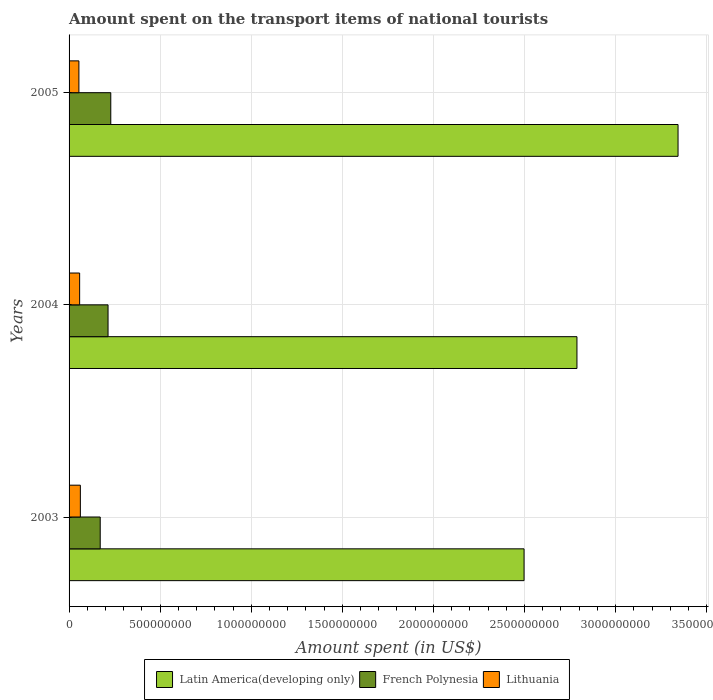How many different coloured bars are there?
Keep it short and to the point. 3. How many groups of bars are there?
Provide a succinct answer. 3. Are the number of bars per tick equal to the number of legend labels?
Provide a short and direct response. Yes. Are the number of bars on each tick of the Y-axis equal?
Offer a very short reply. Yes. How many bars are there on the 3rd tick from the bottom?
Offer a terse response. 3. In how many cases, is the number of bars for a given year not equal to the number of legend labels?
Ensure brevity in your answer.  0. What is the amount spent on the transport items of national tourists in Lithuania in 2005?
Give a very brief answer. 5.40e+07. Across all years, what is the maximum amount spent on the transport items of national tourists in French Polynesia?
Your response must be concise. 2.29e+08. Across all years, what is the minimum amount spent on the transport items of national tourists in French Polynesia?
Ensure brevity in your answer.  1.71e+08. In which year was the amount spent on the transport items of national tourists in Lithuania maximum?
Your response must be concise. 2003. What is the total amount spent on the transport items of national tourists in French Polynesia in the graph?
Offer a terse response. 6.14e+08. What is the difference between the amount spent on the transport items of national tourists in Latin America(developing only) in 2003 and that in 2005?
Offer a terse response. -8.45e+08. What is the difference between the amount spent on the transport items of national tourists in Latin America(developing only) in 2005 and the amount spent on the transport items of national tourists in French Polynesia in 2003?
Keep it short and to the point. 3.17e+09. What is the average amount spent on the transport items of national tourists in Latin America(developing only) per year?
Ensure brevity in your answer.  2.88e+09. In the year 2004, what is the difference between the amount spent on the transport items of national tourists in French Polynesia and amount spent on the transport items of national tourists in Lithuania?
Offer a very short reply. 1.56e+08. In how many years, is the amount spent on the transport items of national tourists in Lithuania greater than 2200000000 US$?
Offer a very short reply. 0. What is the ratio of the amount spent on the transport items of national tourists in Lithuania in 2004 to that in 2005?
Offer a very short reply. 1.07. What is the difference between the highest and the second highest amount spent on the transport items of national tourists in Lithuania?
Ensure brevity in your answer.  4.00e+06. What is the difference between the highest and the lowest amount spent on the transport items of national tourists in Latin America(developing only)?
Keep it short and to the point. 8.45e+08. Is the sum of the amount spent on the transport items of national tourists in French Polynesia in 2003 and 2005 greater than the maximum amount spent on the transport items of national tourists in Latin America(developing only) across all years?
Provide a short and direct response. No. What does the 1st bar from the top in 2004 represents?
Your answer should be very brief. Lithuania. What does the 2nd bar from the bottom in 2004 represents?
Keep it short and to the point. French Polynesia. How many bars are there?
Give a very brief answer. 9. How many years are there in the graph?
Provide a succinct answer. 3. Are the values on the major ticks of X-axis written in scientific E-notation?
Make the answer very short. No. Does the graph contain any zero values?
Make the answer very short. No. Where does the legend appear in the graph?
Your answer should be very brief. Bottom center. How many legend labels are there?
Your response must be concise. 3. How are the legend labels stacked?
Your answer should be very brief. Horizontal. What is the title of the graph?
Keep it short and to the point. Amount spent on the transport items of national tourists. What is the label or title of the X-axis?
Offer a terse response. Amount spent (in US$). What is the Amount spent (in US$) of Latin America(developing only) in 2003?
Your answer should be compact. 2.50e+09. What is the Amount spent (in US$) in French Polynesia in 2003?
Your answer should be very brief. 1.71e+08. What is the Amount spent (in US$) in Lithuania in 2003?
Your answer should be compact. 6.20e+07. What is the Amount spent (in US$) of Latin America(developing only) in 2004?
Provide a succinct answer. 2.79e+09. What is the Amount spent (in US$) in French Polynesia in 2004?
Your response must be concise. 2.14e+08. What is the Amount spent (in US$) of Lithuania in 2004?
Your answer should be compact. 5.80e+07. What is the Amount spent (in US$) of Latin America(developing only) in 2005?
Make the answer very short. 3.34e+09. What is the Amount spent (in US$) of French Polynesia in 2005?
Your answer should be compact. 2.29e+08. What is the Amount spent (in US$) in Lithuania in 2005?
Your answer should be very brief. 5.40e+07. Across all years, what is the maximum Amount spent (in US$) of Latin America(developing only)?
Offer a terse response. 3.34e+09. Across all years, what is the maximum Amount spent (in US$) of French Polynesia?
Make the answer very short. 2.29e+08. Across all years, what is the maximum Amount spent (in US$) of Lithuania?
Make the answer very short. 6.20e+07. Across all years, what is the minimum Amount spent (in US$) in Latin America(developing only)?
Your answer should be compact. 2.50e+09. Across all years, what is the minimum Amount spent (in US$) in French Polynesia?
Give a very brief answer. 1.71e+08. Across all years, what is the minimum Amount spent (in US$) of Lithuania?
Your response must be concise. 5.40e+07. What is the total Amount spent (in US$) in Latin America(developing only) in the graph?
Your response must be concise. 8.63e+09. What is the total Amount spent (in US$) in French Polynesia in the graph?
Provide a short and direct response. 6.14e+08. What is the total Amount spent (in US$) of Lithuania in the graph?
Offer a very short reply. 1.74e+08. What is the difference between the Amount spent (in US$) of Latin America(developing only) in 2003 and that in 2004?
Make the answer very short. -2.90e+08. What is the difference between the Amount spent (in US$) in French Polynesia in 2003 and that in 2004?
Offer a very short reply. -4.30e+07. What is the difference between the Amount spent (in US$) of Lithuania in 2003 and that in 2004?
Provide a succinct answer. 4.00e+06. What is the difference between the Amount spent (in US$) of Latin America(developing only) in 2003 and that in 2005?
Keep it short and to the point. -8.45e+08. What is the difference between the Amount spent (in US$) of French Polynesia in 2003 and that in 2005?
Make the answer very short. -5.80e+07. What is the difference between the Amount spent (in US$) of Lithuania in 2003 and that in 2005?
Your answer should be very brief. 8.00e+06. What is the difference between the Amount spent (in US$) in Latin America(developing only) in 2004 and that in 2005?
Offer a terse response. -5.55e+08. What is the difference between the Amount spent (in US$) in French Polynesia in 2004 and that in 2005?
Give a very brief answer. -1.50e+07. What is the difference between the Amount spent (in US$) of Lithuania in 2004 and that in 2005?
Your answer should be very brief. 4.00e+06. What is the difference between the Amount spent (in US$) of Latin America(developing only) in 2003 and the Amount spent (in US$) of French Polynesia in 2004?
Your answer should be very brief. 2.28e+09. What is the difference between the Amount spent (in US$) of Latin America(developing only) in 2003 and the Amount spent (in US$) of Lithuania in 2004?
Provide a succinct answer. 2.44e+09. What is the difference between the Amount spent (in US$) of French Polynesia in 2003 and the Amount spent (in US$) of Lithuania in 2004?
Give a very brief answer. 1.13e+08. What is the difference between the Amount spent (in US$) in Latin America(developing only) in 2003 and the Amount spent (in US$) in French Polynesia in 2005?
Offer a very short reply. 2.27e+09. What is the difference between the Amount spent (in US$) in Latin America(developing only) in 2003 and the Amount spent (in US$) in Lithuania in 2005?
Ensure brevity in your answer.  2.44e+09. What is the difference between the Amount spent (in US$) in French Polynesia in 2003 and the Amount spent (in US$) in Lithuania in 2005?
Offer a terse response. 1.17e+08. What is the difference between the Amount spent (in US$) of Latin America(developing only) in 2004 and the Amount spent (in US$) of French Polynesia in 2005?
Make the answer very short. 2.56e+09. What is the difference between the Amount spent (in US$) of Latin America(developing only) in 2004 and the Amount spent (in US$) of Lithuania in 2005?
Your answer should be compact. 2.73e+09. What is the difference between the Amount spent (in US$) in French Polynesia in 2004 and the Amount spent (in US$) in Lithuania in 2005?
Make the answer very short. 1.60e+08. What is the average Amount spent (in US$) in Latin America(developing only) per year?
Offer a terse response. 2.88e+09. What is the average Amount spent (in US$) in French Polynesia per year?
Keep it short and to the point. 2.05e+08. What is the average Amount spent (in US$) in Lithuania per year?
Make the answer very short. 5.80e+07. In the year 2003, what is the difference between the Amount spent (in US$) of Latin America(developing only) and Amount spent (in US$) of French Polynesia?
Ensure brevity in your answer.  2.33e+09. In the year 2003, what is the difference between the Amount spent (in US$) of Latin America(developing only) and Amount spent (in US$) of Lithuania?
Your answer should be very brief. 2.44e+09. In the year 2003, what is the difference between the Amount spent (in US$) in French Polynesia and Amount spent (in US$) in Lithuania?
Offer a very short reply. 1.09e+08. In the year 2004, what is the difference between the Amount spent (in US$) in Latin America(developing only) and Amount spent (in US$) in French Polynesia?
Keep it short and to the point. 2.57e+09. In the year 2004, what is the difference between the Amount spent (in US$) in Latin America(developing only) and Amount spent (in US$) in Lithuania?
Ensure brevity in your answer.  2.73e+09. In the year 2004, what is the difference between the Amount spent (in US$) in French Polynesia and Amount spent (in US$) in Lithuania?
Make the answer very short. 1.56e+08. In the year 2005, what is the difference between the Amount spent (in US$) of Latin America(developing only) and Amount spent (in US$) of French Polynesia?
Make the answer very short. 3.11e+09. In the year 2005, what is the difference between the Amount spent (in US$) in Latin America(developing only) and Amount spent (in US$) in Lithuania?
Your answer should be very brief. 3.29e+09. In the year 2005, what is the difference between the Amount spent (in US$) of French Polynesia and Amount spent (in US$) of Lithuania?
Give a very brief answer. 1.75e+08. What is the ratio of the Amount spent (in US$) in Latin America(developing only) in 2003 to that in 2004?
Make the answer very short. 0.9. What is the ratio of the Amount spent (in US$) of French Polynesia in 2003 to that in 2004?
Provide a succinct answer. 0.8. What is the ratio of the Amount spent (in US$) in Lithuania in 2003 to that in 2004?
Offer a terse response. 1.07. What is the ratio of the Amount spent (in US$) of Latin America(developing only) in 2003 to that in 2005?
Provide a short and direct response. 0.75. What is the ratio of the Amount spent (in US$) of French Polynesia in 2003 to that in 2005?
Your answer should be very brief. 0.75. What is the ratio of the Amount spent (in US$) in Lithuania in 2003 to that in 2005?
Ensure brevity in your answer.  1.15. What is the ratio of the Amount spent (in US$) in Latin America(developing only) in 2004 to that in 2005?
Your answer should be compact. 0.83. What is the ratio of the Amount spent (in US$) of French Polynesia in 2004 to that in 2005?
Offer a very short reply. 0.93. What is the ratio of the Amount spent (in US$) of Lithuania in 2004 to that in 2005?
Ensure brevity in your answer.  1.07. What is the difference between the highest and the second highest Amount spent (in US$) of Latin America(developing only)?
Give a very brief answer. 5.55e+08. What is the difference between the highest and the second highest Amount spent (in US$) of French Polynesia?
Keep it short and to the point. 1.50e+07. What is the difference between the highest and the second highest Amount spent (in US$) of Lithuania?
Your response must be concise. 4.00e+06. What is the difference between the highest and the lowest Amount spent (in US$) in Latin America(developing only)?
Give a very brief answer. 8.45e+08. What is the difference between the highest and the lowest Amount spent (in US$) in French Polynesia?
Provide a succinct answer. 5.80e+07. 